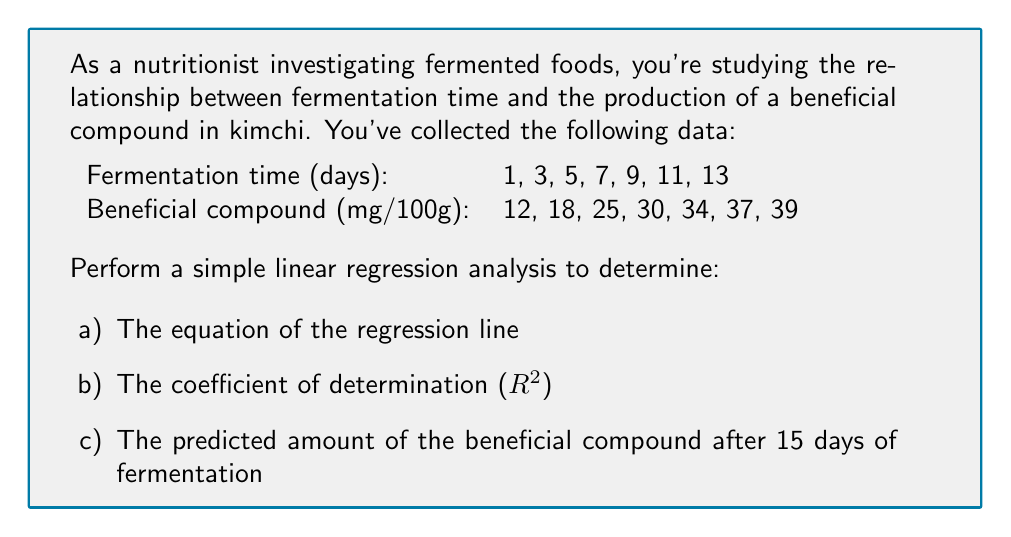Can you answer this question? Let's perform the regression analysis step by step:

1. Calculate the means of x (fermentation time) and y (beneficial compound):
   $$\bar{x} = \frac{1 + 3 + 5 + 7 + 9 + 11 + 13}{7} = 7$$
   $$\bar{y} = \frac{12 + 18 + 25 + 30 + 34 + 37 + 39}{7} = 27.857$$

2. Calculate the sums of squares:
   $$SS_{xx} = \sum(x_i - \bar{x})^2 = 168$$
   $$SS_{yy} = \sum(y_i - \bar{y})^2 = 756.857$$
   $$SS_{xy} = \sum(x_i - \bar{x})(y_i - \bar{y}) = 350$$

3. Calculate the slope (b) and y-intercept (a) of the regression line:
   $$b = \frac{SS_{xy}}{SS_{xx}} = \frac{350}{168} = 2.083$$
   $$a = \bar{y} - b\bar{x} = 27.857 - 2.083(7) = 13.276$$

   The equation of the regression line is:
   $$y = 2.083x + 13.276$$

4. Calculate the coefficient of determination (R-squared):
   $$R^2 = \frac{(SS_{xy})^2}{SS_{xx} \cdot SS_{yy}} = \frac{350^2}{168 \cdot 756.857} = 0.966$$

5. Predict the amount of beneficial compound after 15 days:
   $$y = 2.083(15) + 13.276 = 44.521$$
Answer: a) Regression line equation: $y = 2.083x + 13.276$
b) Coefficient of determination (R-squared): $R^2 = 0.966$
c) Predicted amount of beneficial compound after 15 days: 44.521 mg/100g 